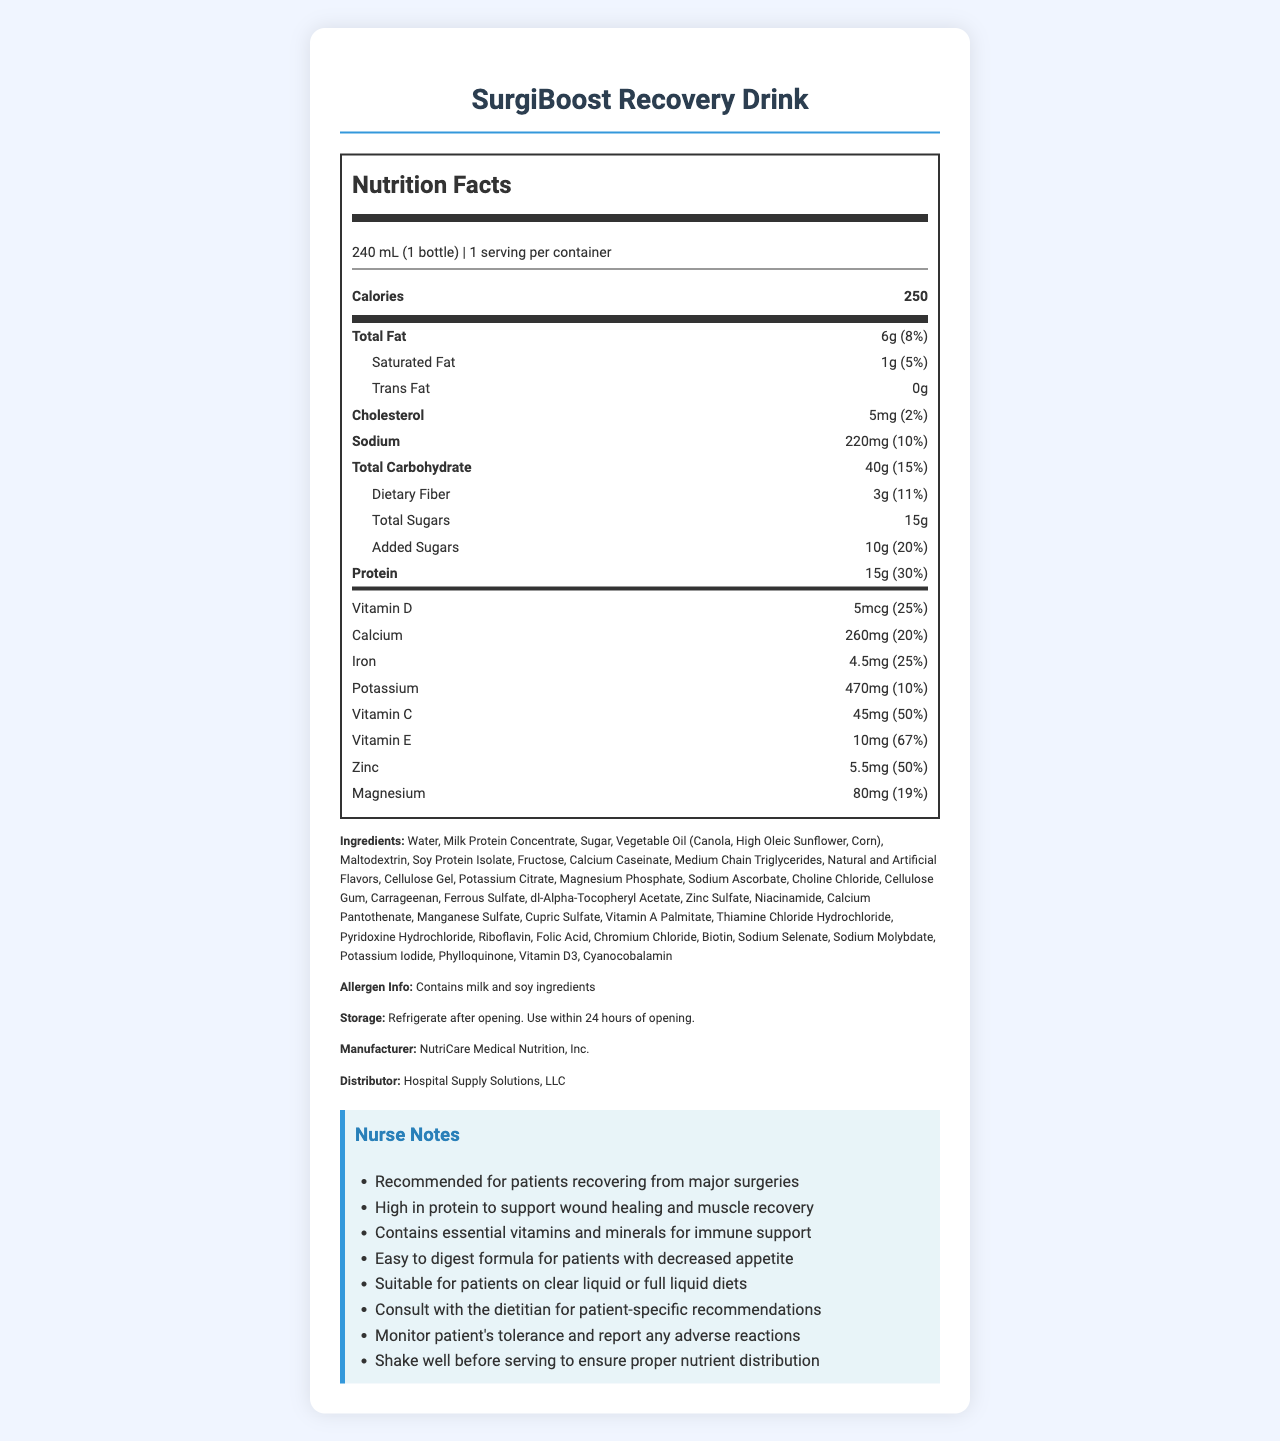which product does the document describe? The document is titled "Nutrition Facts: SurgiBoost Recovery Drink" and lists details about this product.
Answer: SurgiBoost Recovery Drink what is the serving size of the product? The serving size is mentioned right at the top under "Nutrition Facts" as "240 mL (1 bottle)."
Answer: 240 mL (1 bottle) how many calories does one serving contain? The calories per serving are highlighted under the main nutrients section: "Calories 250."
Answer: 250 how much saturated fat does the product contain? The saturated fat amount and its daily value are listed among the sub-nutrients as "Saturated Fat 1g (5%)."
Answer: 1g what percentage of the daily value does protein account for? The daily value percentage for protein is given as "30%" next to its amount "15g."
Answer: 30% which mineral has the highest daily value percentage? A. Calcium B. Iron C. Zinc D. Magnesium Zinc has the highest daily value percentage at 50%, compared to Calcium (20%), Iron (25%), and Magnesium (19%).
Answer: C. Zinc which of these vitamins is present in the highest amount? A. Vitamin C B. Vitamin D C. Vitamin E D. Magnesium Vitamin C is present in the highest amount at 45mg, compared to Vitamin D (5mcg), Vitamin E (10mg), and Magnesium (80mg).
Answer: A. Vitamin C does the product contain any allergens? The allergen information states "Contains milk and soy ingredients."
Answer: Yes is the product suitable for patients on full liquid diets? According to the nurse notes, it is "suitable for patients on clear liquid or full liquid diets."
Answer: Yes what are some of the key features of this product as highlighted in the nurse notes? The nurse notes list several key features: high in protein, contains essential vitamins and minerals, easy to digest, and shake well before serving.
Answer: High in protein, essential vitamins and minerals, easy to digest, shake well before serving summarize the main purpose of the SurgiBoost Recovery Drink. The drink is described as a nutritional supplement that aids in recovery post-surgery, with high protein for healing, a range of essential vitamins and minerals, and an easy-to-digest formula. It is suitable for various patient dietary needs and comes with specific handling instructions.
Answer: The SurgiBoost Recovery Drink is a nutritional supplement designed for patients recovering from surgery. It offers high protein, essential vitamins and minerals, and is easy to digest. It supports wound healing, muscle recovery, and overall immune support. who distributes the SurgiBoost Recovery Drink? The distributor is mentioned near the end of the document as "Hospital Supply Solutions, LLC,".
Answer: Hospital Supply Solutions, LLC what is the recommended consumption timeline after opening the product? The storage instructions specify to "use within 24 hours of opening."
Answer: 24 hours what protein sources are contained in the drink? The ingredients list includes "Milk Protein Concentrate," "Soy Protein Isolate," and "Calcium Caseinate" as protein sources.
Answer: Milk Protein Concentrate, Soy Protein Isolate, Calcium Caseinate which ingredient is not listed in the document? A. Water B. Sugar C. Aspartame D. Fructose The ingredient list includes Water, Sugar, and Fructose, but not Aspartame.
Answer: C. Aspartame what's the amount of sodium per serving and its daily value percentage? Sodium content per serving is 220mg with a daily value of 10% listed in the nutrient section.
Answer: 220mg, 10% how does the drink support wound healing and muscle recovery? The nurse notes indicate that the drink is high in protein, which supports wound healing and muscle recovery.
Answer: High in protein can the expiration date of the product be determined from the document? The visual information provided in the document does not include the expiration date of the product.
Answer: Cannot be determined 